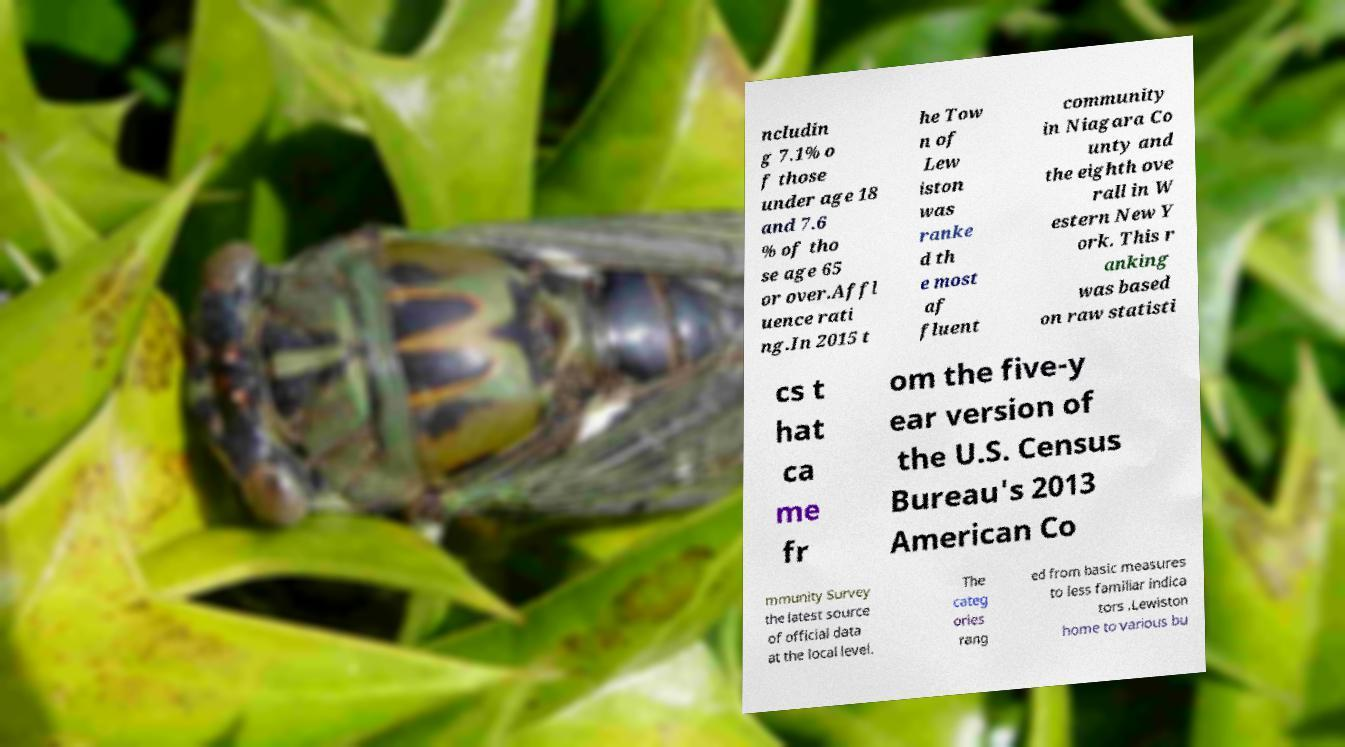Could you assist in decoding the text presented in this image and type it out clearly? ncludin g 7.1% o f those under age 18 and 7.6 % of tho se age 65 or over.Affl uence rati ng.In 2015 t he Tow n of Lew iston was ranke d th e most af fluent community in Niagara Co unty and the eighth ove rall in W estern New Y ork. This r anking was based on raw statisti cs t hat ca me fr om the five-y ear version of the U.S. Census Bureau's 2013 American Co mmunity Survey the latest source of official data at the local level. The categ ories rang ed from basic measures to less familiar indica tors .Lewiston home to various bu 